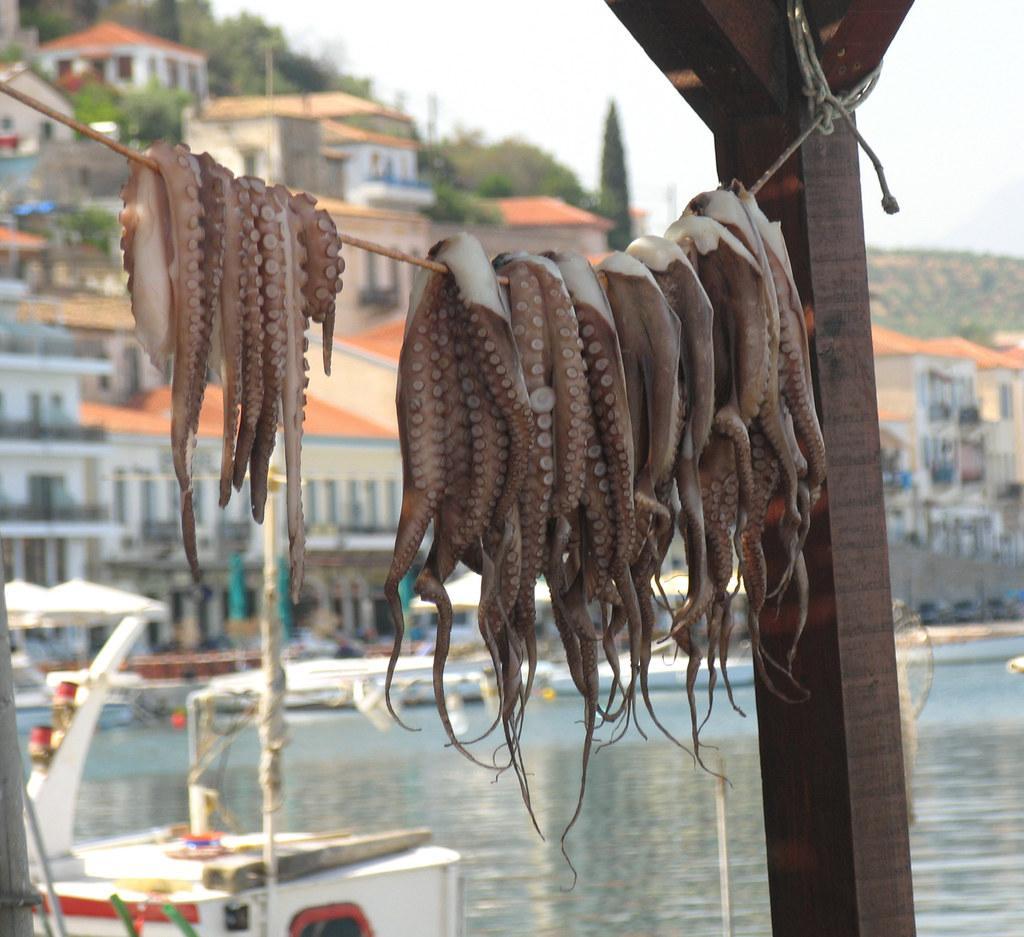In one or two sentences, can you explain what this image depicts? In this image it seems like there are few octopus which are hanged on the rope. In the background there are buildings one beside the other. At the bottom there is water. In between the buildings there are trees. In the water there are boats. 